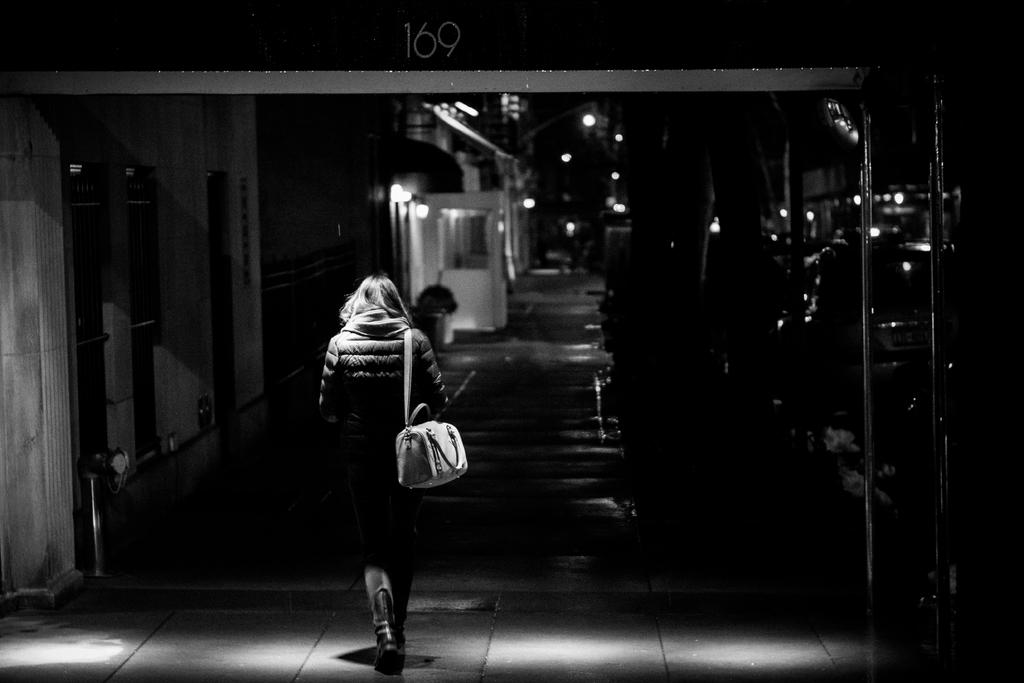Who is present in the image? There is a woman in the image. What is the woman wearing? The woman is wearing a bag. What is the woman doing in the image? The woman is walking. What can be seen in the background of the image? There are lights and windows visible in the image, and the background is dark. How many kittens are sitting on the pancake in the image? There are no kittens or pancakes present in the image. What type of shoes is the woman wearing in the image? The provided facts do not mention the woman's shoes, so we cannot determine the type of shoes she is wearing. 